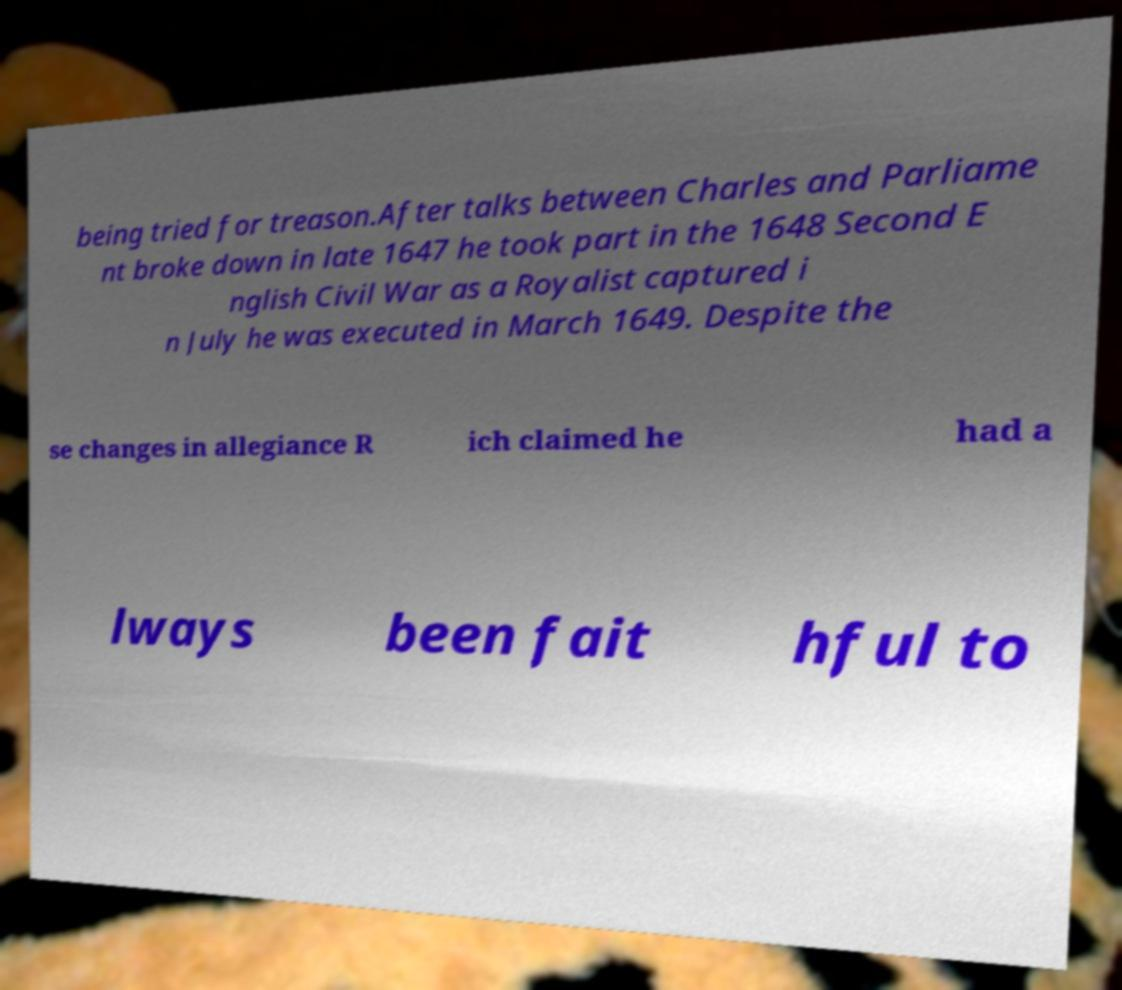Could you extract and type out the text from this image? being tried for treason.After talks between Charles and Parliame nt broke down in late 1647 he took part in the 1648 Second E nglish Civil War as a Royalist captured i n July he was executed in March 1649. Despite the se changes in allegiance R ich claimed he had a lways been fait hful to 